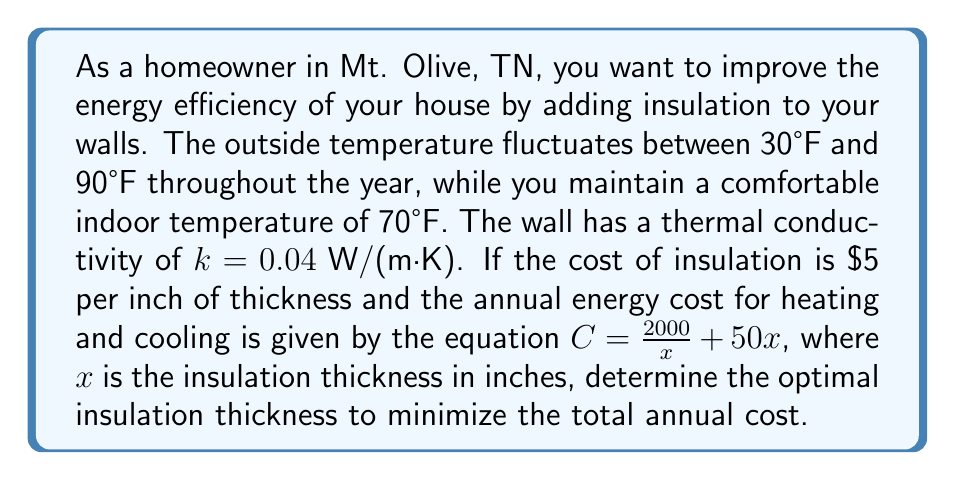Solve this math problem. To solve this problem, we'll use concepts from heat transfer and optimization. Let's approach this step-by-step:

1) The total annual cost is the sum of the insulation cost and the energy cost:

   $C_{\text{total}} = C_{\text{insulation}} + C_{\text{energy}}$

2) The insulation cost is $\$5$ per inch, so for thickness $x$:
   
   $C_{\text{insulation}} = 5x$

3) The energy cost is given by:

   $C_{\text{energy}} = \frac{2000}{x} + 50x$

4) Therefore, the total cost function is:

   $C_{\text{total}} = 5x + \frac{2000}{x} + 50x = 55x + \frac{2000}{x}$

5) To find the minimum cost, we need to find where the derivative of this function equals zero:

   $\frac{dC_{\text{total}}}{dx} = 55 - \frac{2000}{x^2} = 0$

6) Solving this equation:

   $55 = \frac{2000}{x^2}$
   $x^2 = \frac{2000}{55}$
   $x = \sqrt{\frac{2000}{55}} \approx 6.03$ inches

7) To confirm this is a minimum, we can check the second derivative:

   $\frac{d^2C_{\text{total}}}{dx^2} = \frac{4000}{x^3}$

   This is always positive for positive $x$, confirming we've found a minimum.

8) Rounding to the nearest practical thickness, the optimal insulation thickness is 6 inches.

This solution minimizes the total annual cost by balancing the upfront cost of insulation with the long-term energy savings.
Answer: The optimal insulation thickness is approximately 6 inches. 